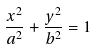<formula> <loc_0><loc_0><loc_500><loc_500>\frac { x ^ { 2 } } { a ^ { 2 } } + \frac { y ^ { 2 } } { b ^ { 2 } } = 1</formula> 